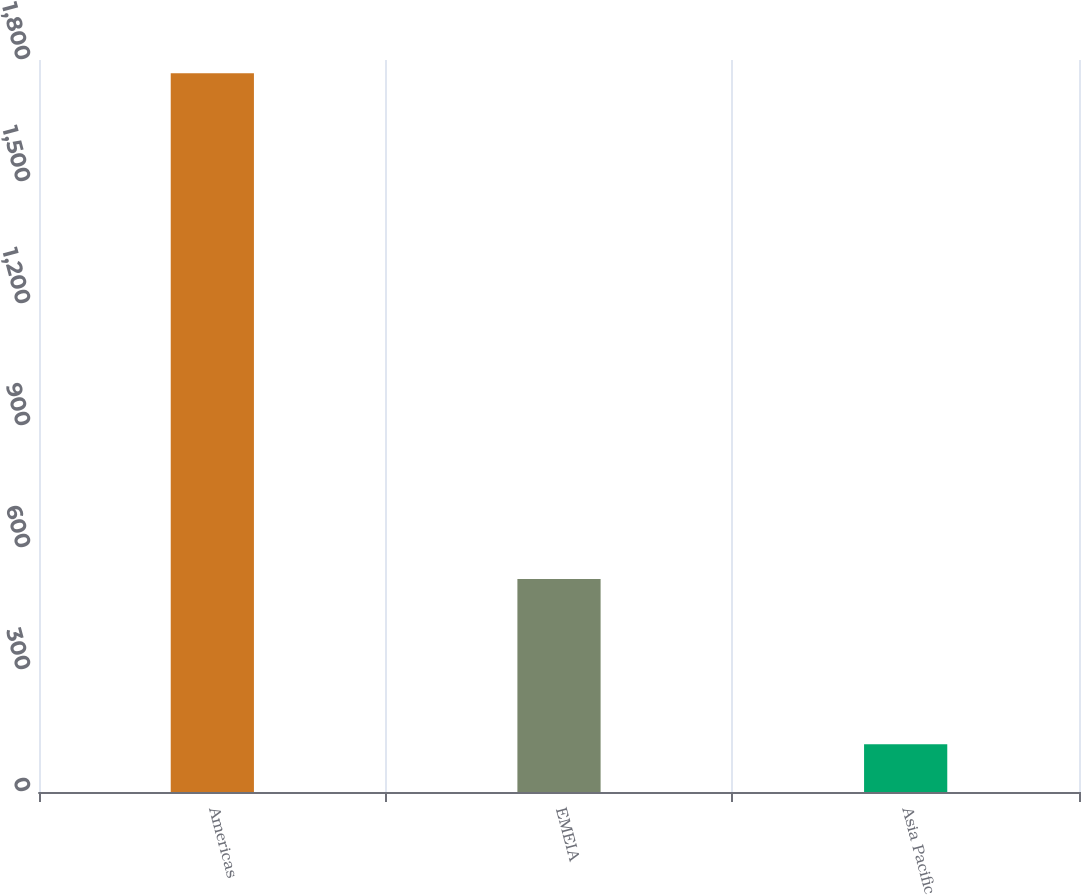Convert chart. <chart><loc_0><loc_0><loc_500><loc_500><bar_chart><fcel>Americas<fcel>EMEIA<fcel>Asia Pacific<nl><fcel>1767.5<fcel>523.5<fcel>117.2<nl></chart> 